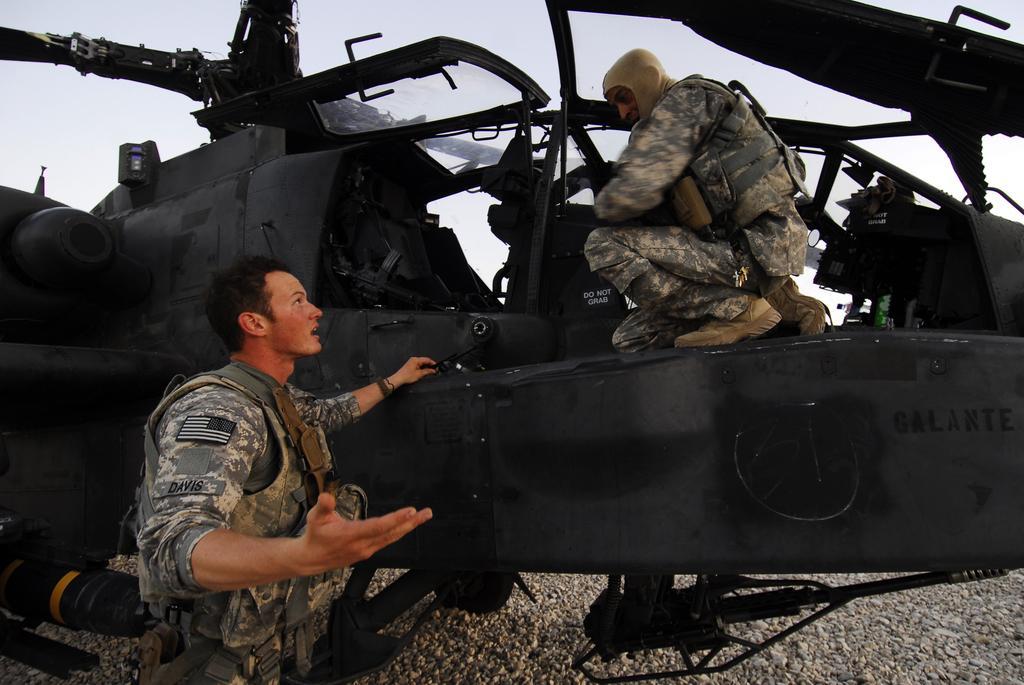Please provide a concise description of this image. In the picture I can see two men are wearing uniforms. Among these men one man is standing on the ground and other man is on a helicopter. In the background I can see the sky. 